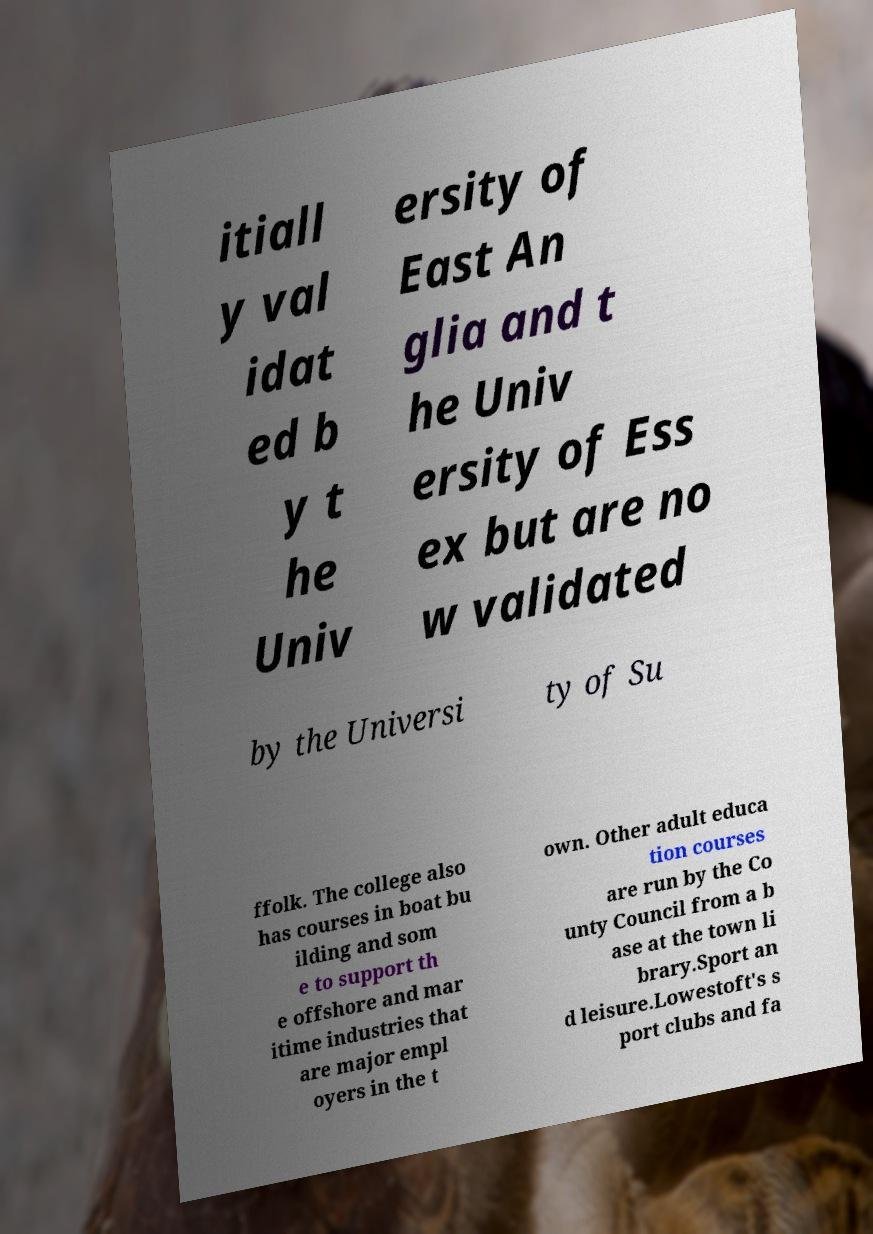Please identify and transcribe the text found in this image. itiall y val idat ed b y t he Univ ersity of East An glia and t he Univ ersity of Ess ex but are no w validated by the Universi ty of Su ffolk. The college also has courses in boat bu ilding and som e to support th e offshore and mar itime industries that are major empl oyers in the t own. Other adult educa tion courses are run by the Co unty Council from a b ase at the town li brary.Sport an d leisure.Lowestoft's s port clubs and fa 